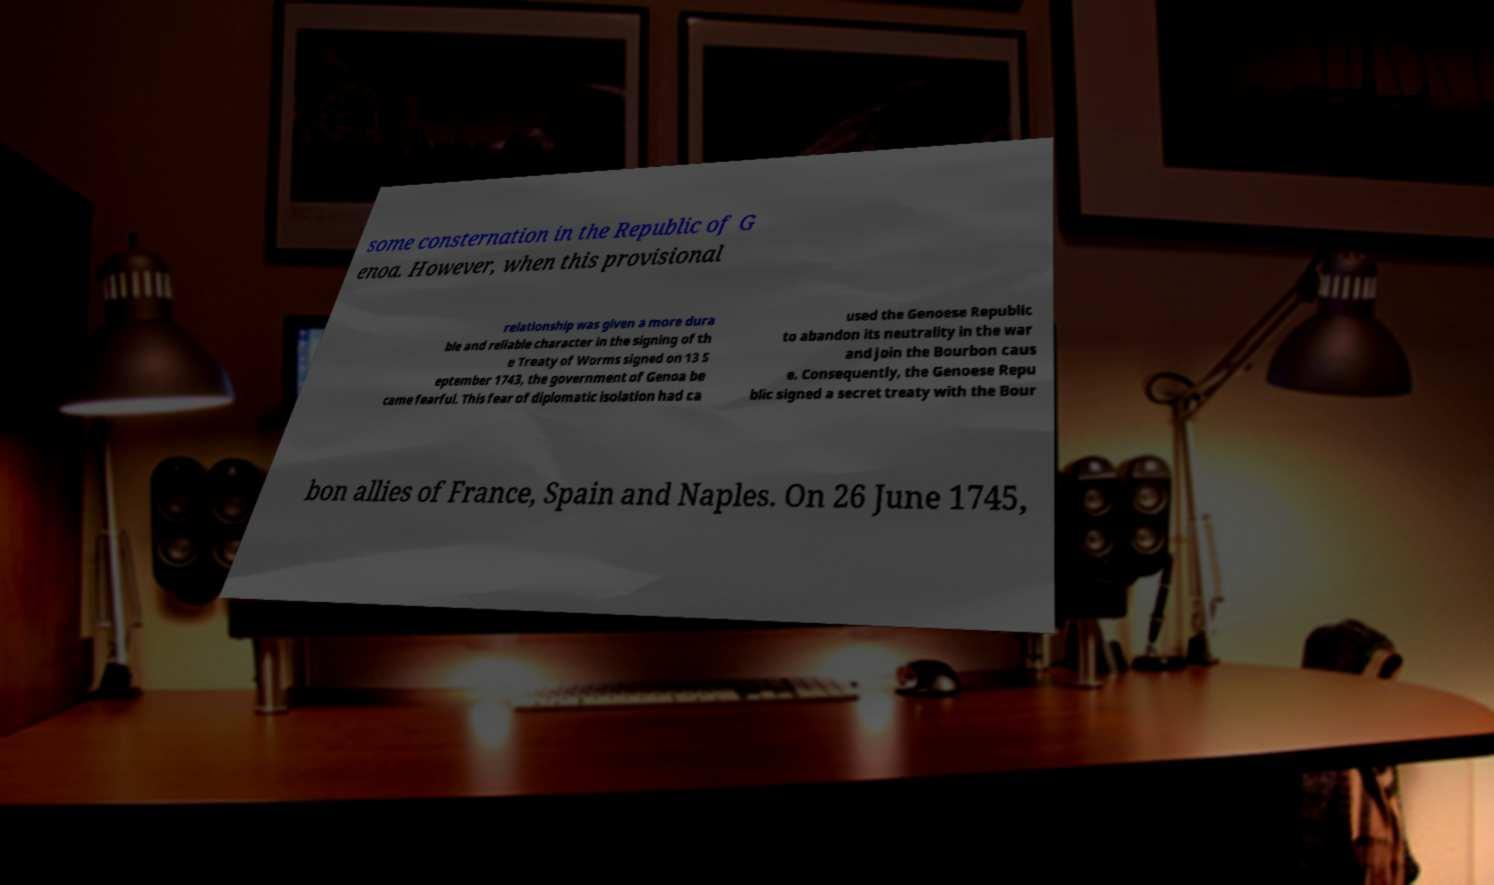Please read and relay the text visible in this image. What does it say? some consternation in the Republic of G enoa. However, when this provisional relationship was given a more dura ble and reliable character in the signing of th e Treaty of Worms signed on 13 S eptember 1743, the government of Genoa be came fearful. This fear of diplomatic isolation had ca used the Genoese Republic to abandon its neutrality in the war and join the Bourbon caus e. Consequently, the Genoese Repu blic signed a secret treaty with the Bour bon allies of France, Spain and Naples. On 26 June 1745, 